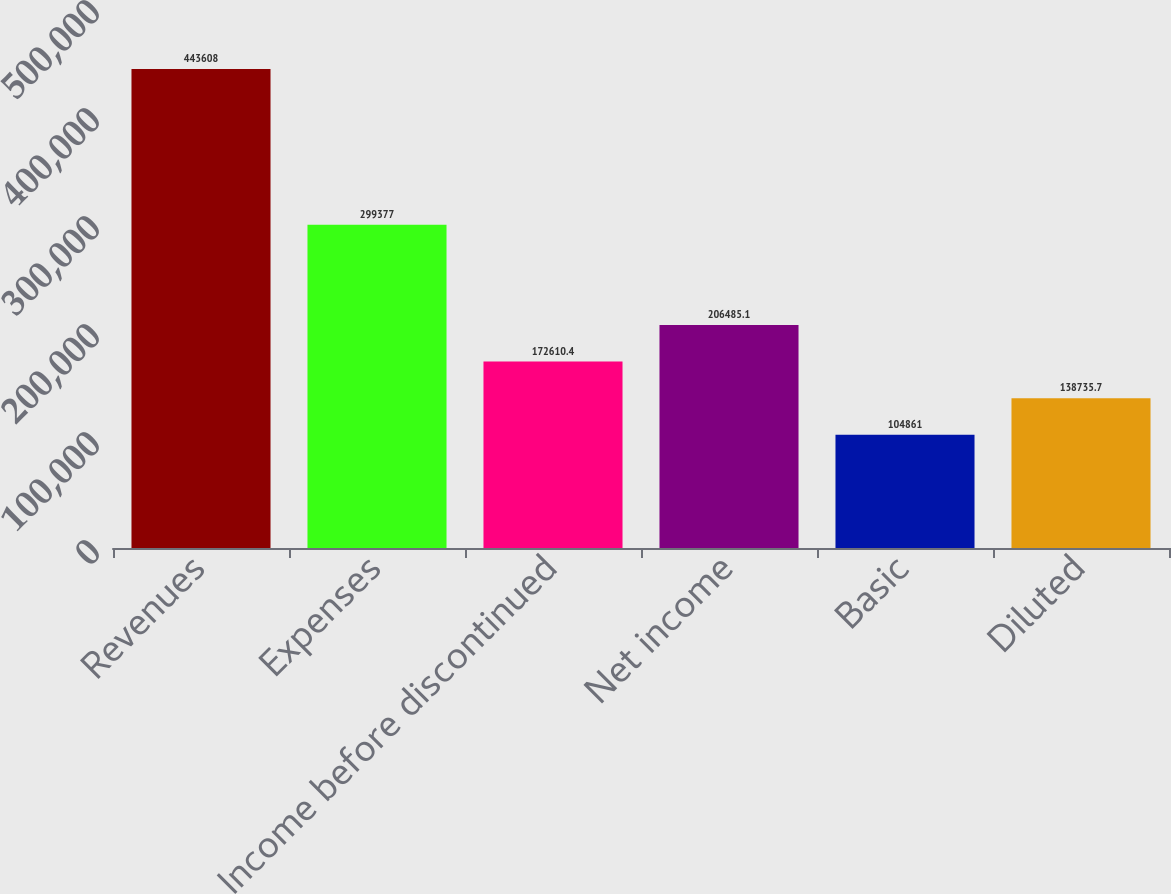Convert chart to OTSL. <chart><loc_0><loc_0><loc_500><loc_500><bar_chart><fcel>Revenues<fcel>Expenses<fcel>Income before discontinued<fcel>Net income<fcel>Basic<fcel>Diluted<nl><fcel>443608<fcel>299377<fcel>172610<fcel>206485<fcel>104861<fcel>138736<nl></chart> 